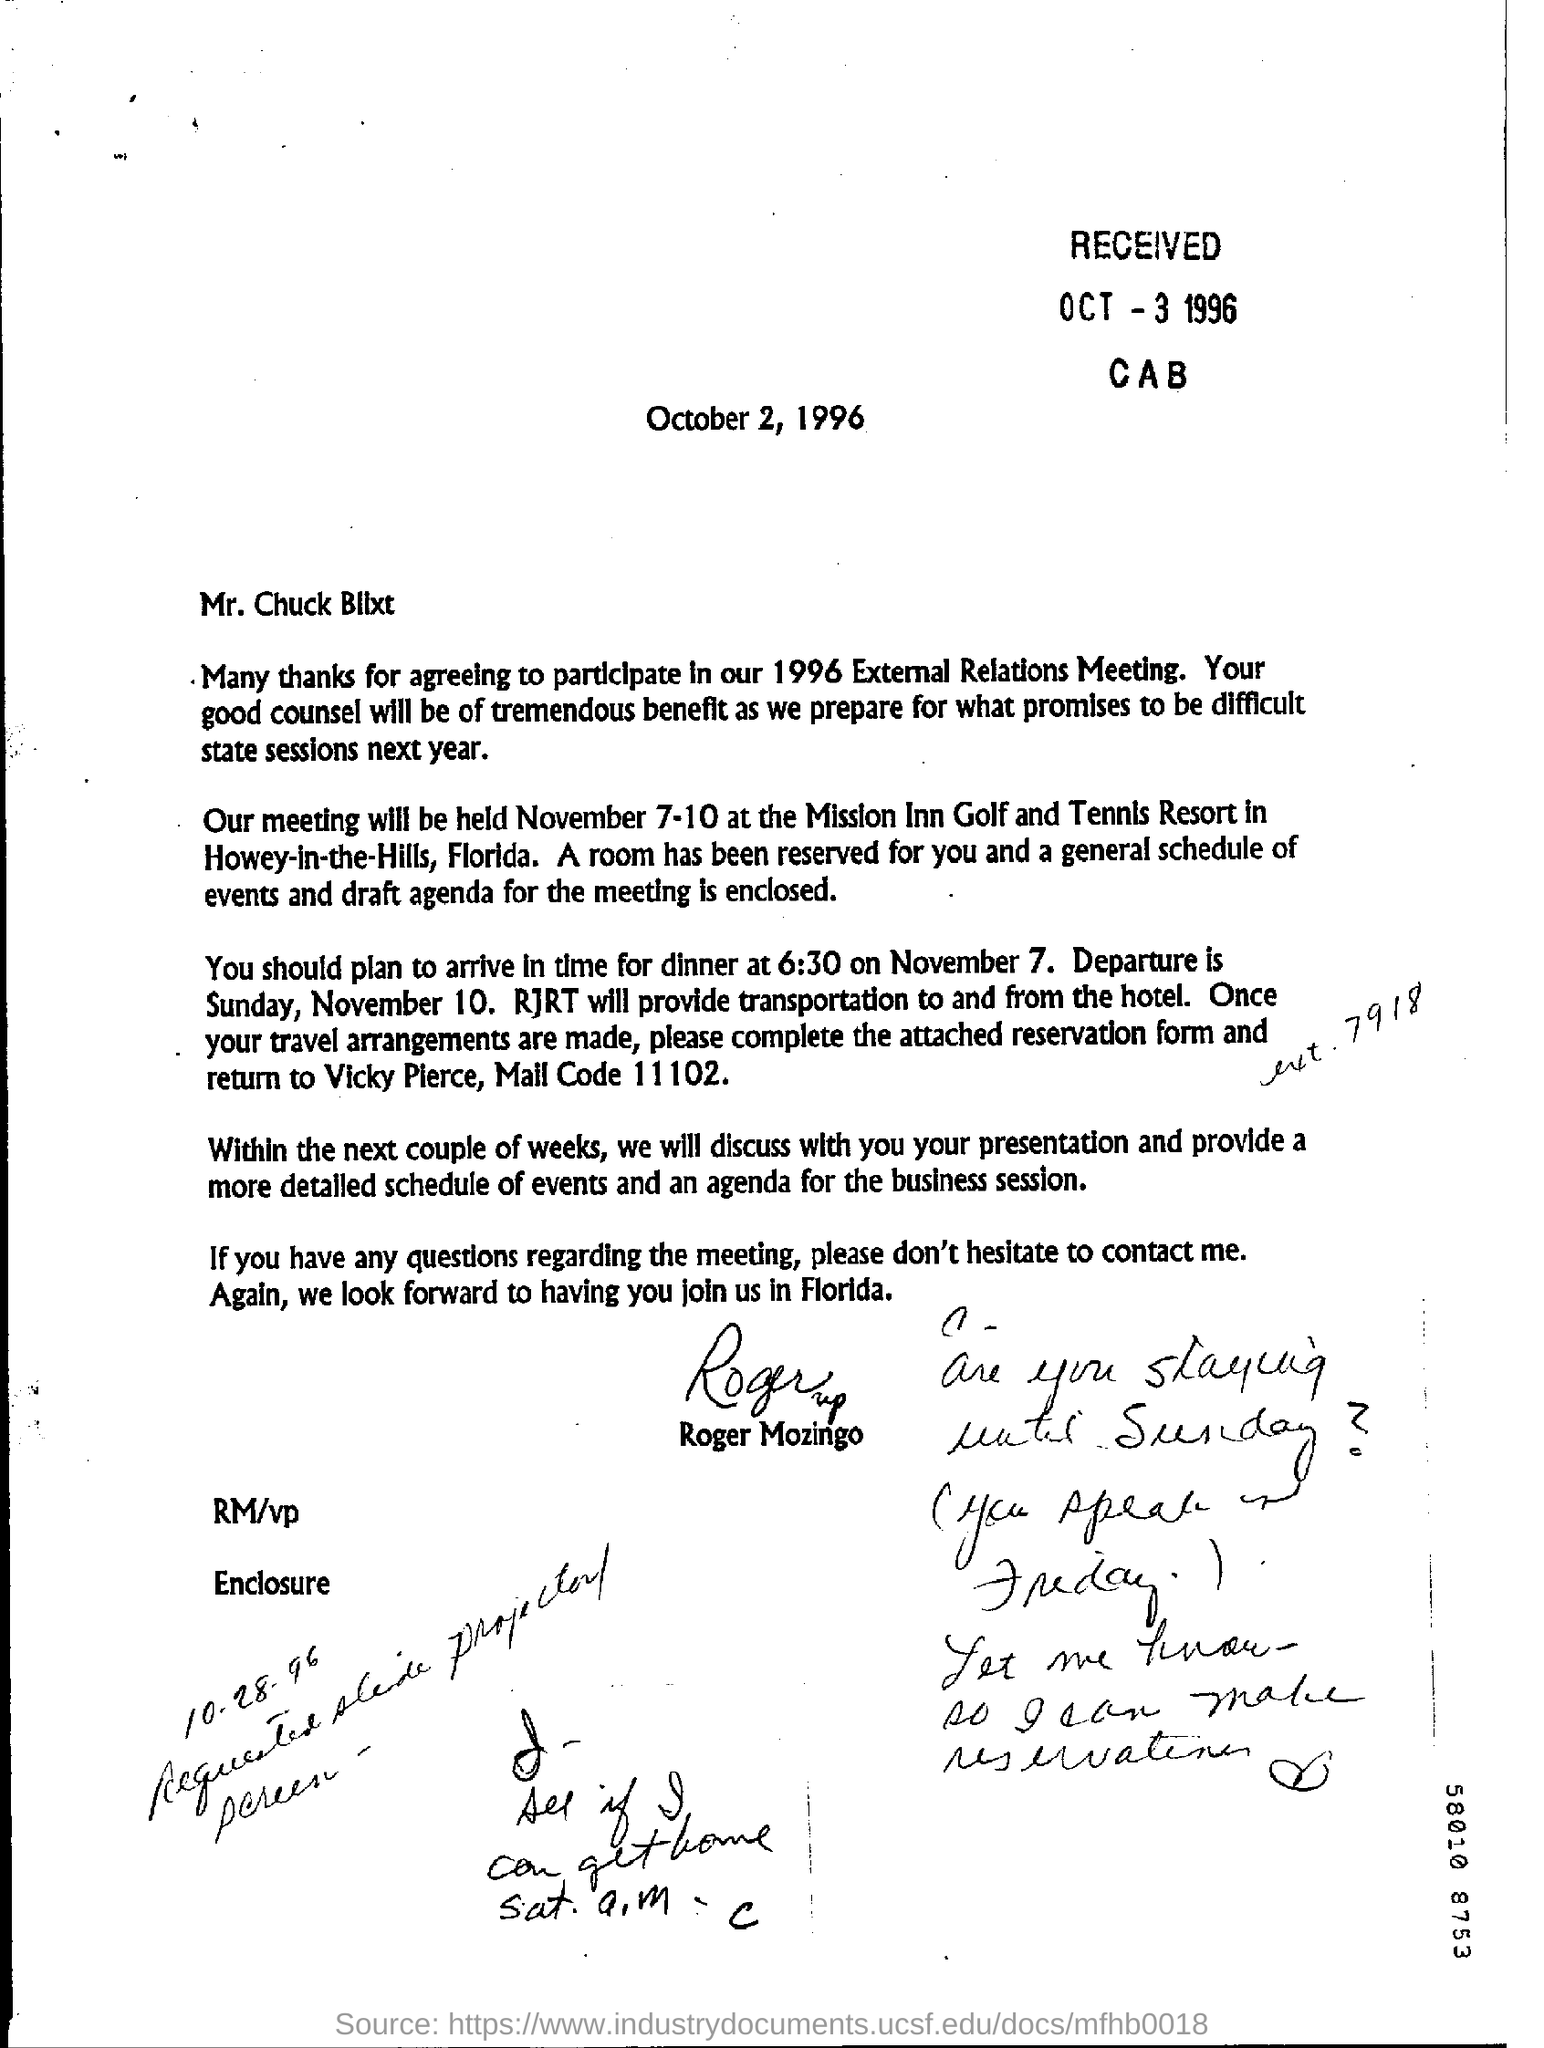Identify some key points in this picture. The date of departure is November 10. The received date is October 3, 1996. The year mentioned is 1996. The letter is addressed to Mr. Charles Bllxt. The meeting will be held at the place known as Howey-in-the-Hills, Florida. 